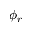Convert formula to latex. <formula><loc_0><loc_0><loc_500><loc_500>\phi _ { r }</formula> 